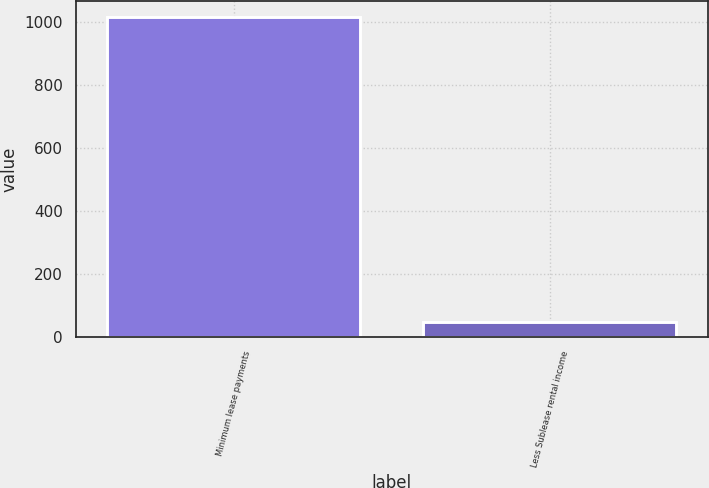Convert chart. <chart><loc_0><loc_0><loc_500><loc_500><bar_chart><fcel>Minimum lease payments<fcel>Less Sublease rental income<nl><fcel>1017<fcel>46<nl></chart> 